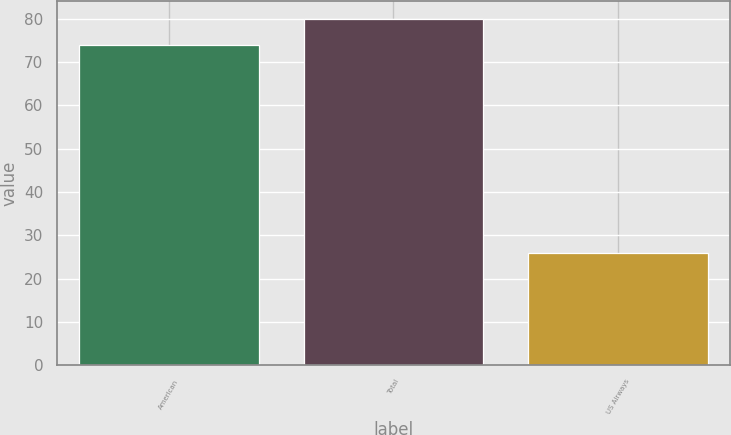<chart> <loc_0><loc_0><loc_500><loc_500><bar_chart><fcel>American<fcel>Total<fcel>US Airways<nl><fcel>74<fcel>80<fcel>26<nl></chart> 